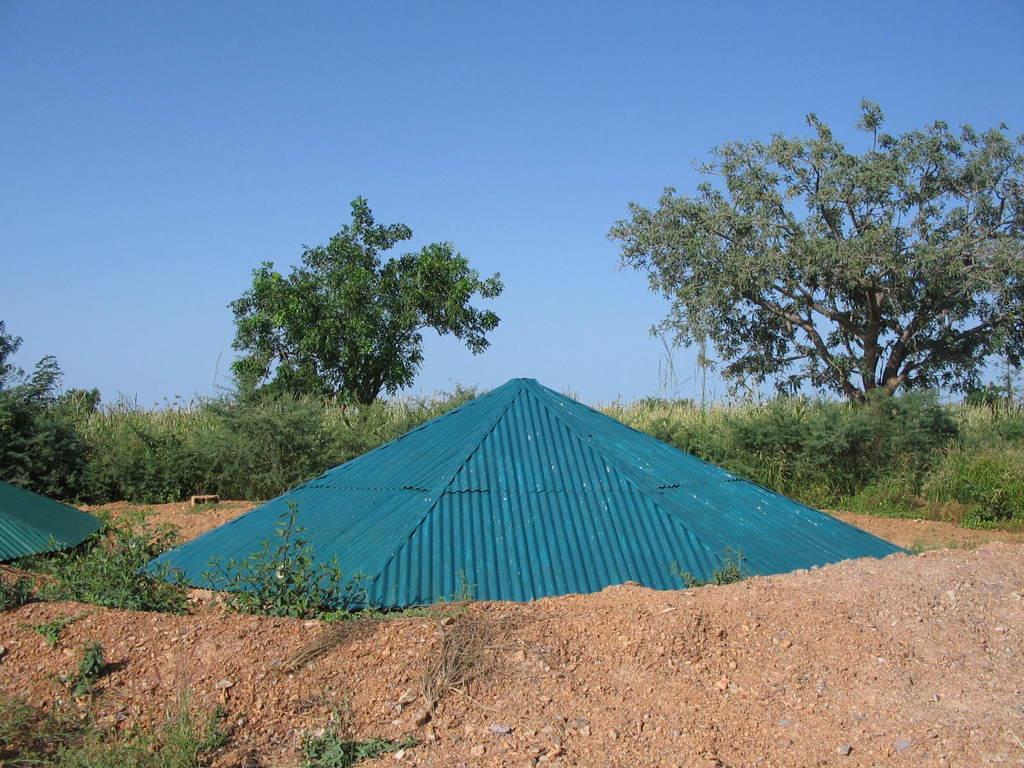In one or two sentences, can you explain what this image depicts? In front of the image there are some objects, behind them there are plants and trees. 